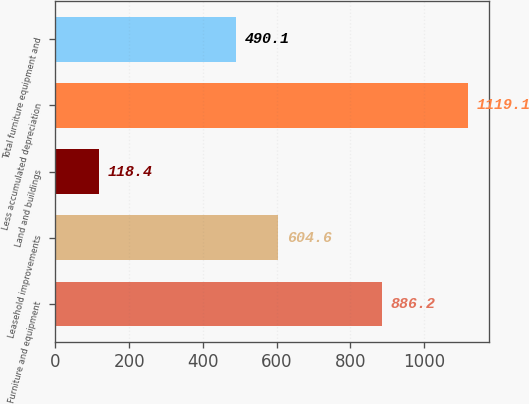Convert chart to OTSL. <chart><loc_0><loc_0><loc_500><loc_500><bar_chart><fcel>Furniture and equipment<fcel>Leasehold improvements<fcel>Land and buildings<fcel>Less accumulated depreciation<fcel>Total furniture equipment and<nl><fcel>886.2<fcel>604.6<fcel>118.4<fcel>1119.1<fcel>490.1<nl></chart> 